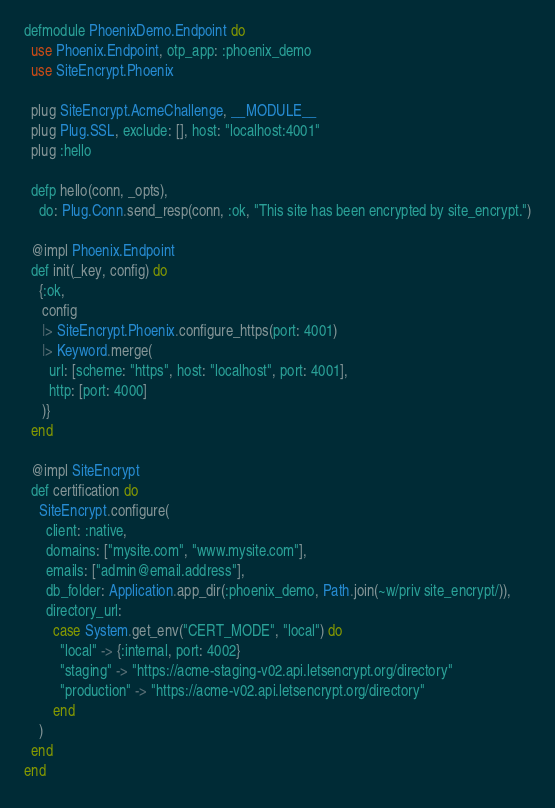Convert code to text. <code><loc_0><loc_0><loc_500><loc_500><_Elixir_>defmodule PhoenixDemo.Endpoint do
  use Phoenix.Endpoint, otp_app: :phoenix_demo
  use SiteEncrypt.Phoenix

  plug SiteEncrypt.AcmeChallenge, __MODULE__
  plug Plug.SSL, exclude: [], host: "localhost:4001"
  plug :hello

  defp hello(conn, _opts),
    do: Plug.Conn.send_resp(conn, :ok, "This site has been encrypted by site_encrypt.")

  @impl Phoenix.Endpoint
  def init(_key, config) do
    {:ok,
     config
     |> SiteEncrypt.Phoenix.configure_https(port: 4001)
     |> Keyword.merge(
       url: [scheme: "https", host: "localhost", port: 4001],
       http: [port: 4000]
     )}
  end

  @impl SiteEncrypt
  def certification do
    SiteEncrypt.configure(
      client: :native,
      domains: ["mysite.com", "www.mysite.com"],
      emails: ["admin@email.address"],
      db_folder: Application.app_dir(:phoenix_demo, Path.join(~w/priv site_encrypt/)),
      directory_url:
        case System.get_env("CERT_MODE", "local") do
          "local" -> {:internal, port: 4002}
          "staging" -> "https://acme-staging-v02.api.letsencrypt.org/directory"
          "production" -> "https://acme-v02.api.letsencrypt.org/directory"
        end
    )
  end
end
</code> 